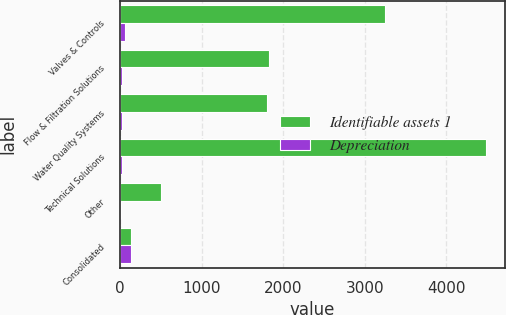Convert chart to OTSL. <chart><loc_0><loc_0><loc_500><loc_500><stacked_bar_chart><ecel><fcel>Valves & Controls<fcel>Flow & Filtration Solutions<fcel>Water Quality Systems<fcel>Technical Solutions<fcel>Other<fcel>Consolidated<nl><fcel>Identifiable assets 1<fcel>3243.3<fcel>1822.8<fcel>1801.7<fcel>4488.4<fcel>500.8<fcel>139.5<nl><fcel>Depreciation<fcel>58.3<fcel>23.6<fcel>21.7<fcel>27.6<fcel>8.3<fcel>139.5<nl></chart> 